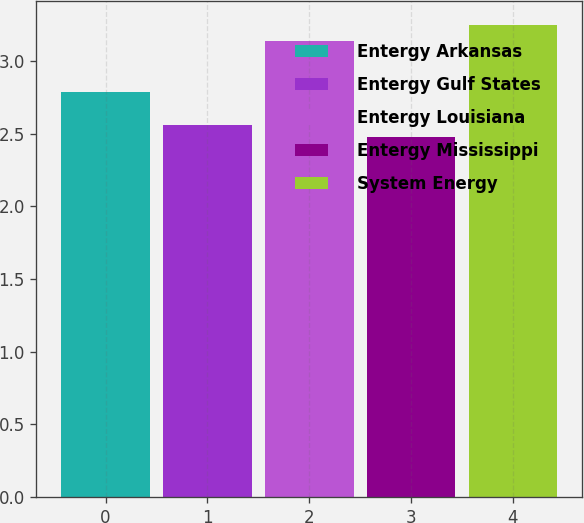<chart> <loc_0><loc_0><loc_500><loc_500><bar_chart><fcel>Entergy Arkansas<fcel>Entergy Gulf States<fcel>Entergy Louisiana<fcel>Entergy Mississippi<fcel>System Energy<nl><fcel>2.79<fcel>2.56<fcel>3.14<fcel>2.48<fcel>3.25<nl></chart> 